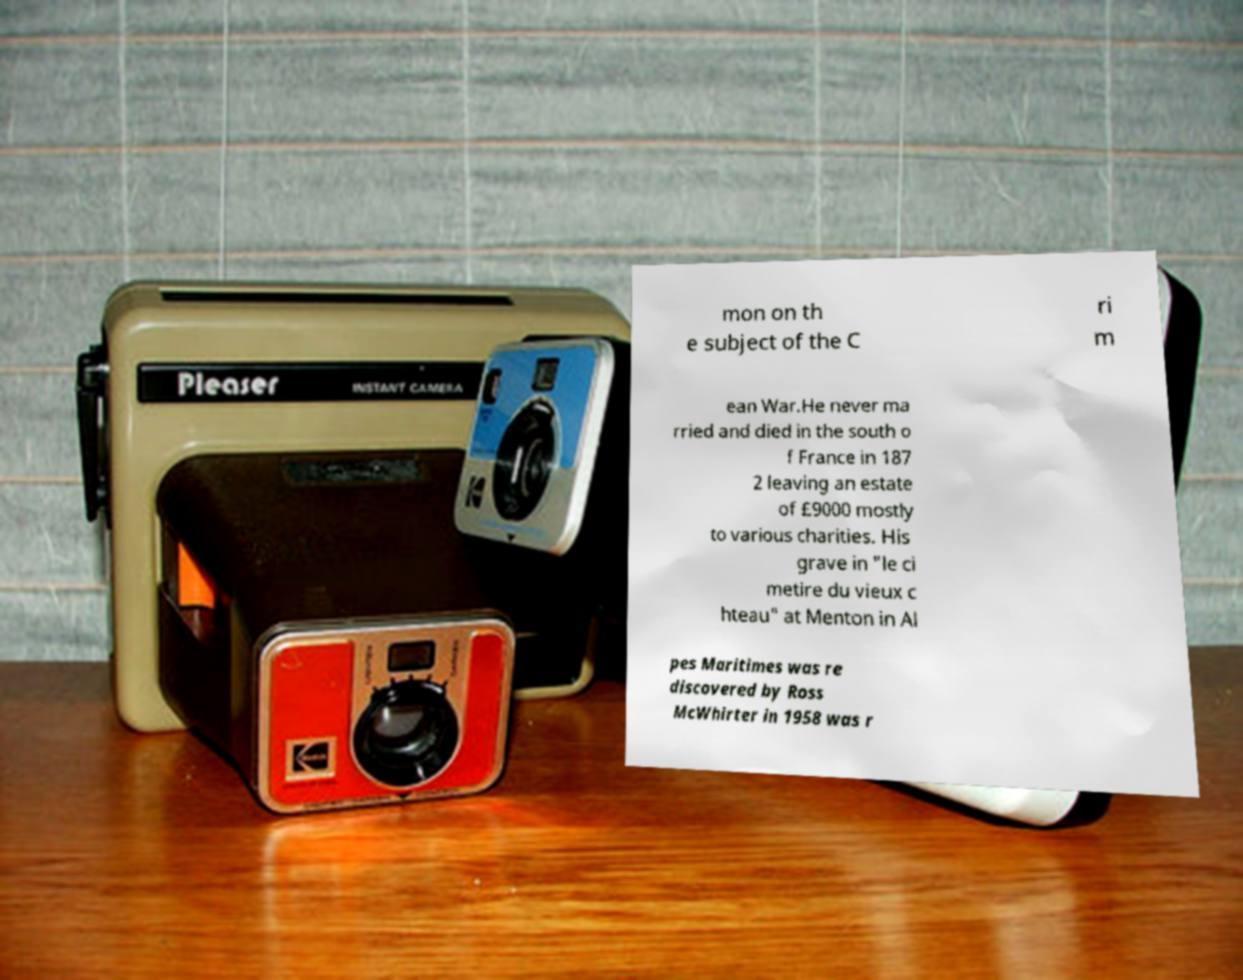I need the written content from this picture converted into text. Can you do that? mon on th e subject of the C ri m ean War.He never ma rried and died in the south o f France in 187 2 leaving an estate of £9000 mostly to various charities. His grave in "le ci metire du vieux c hteau" at Menton in Al pes Maritimes was re discovered by Ross McWhirter in 1958 was r 